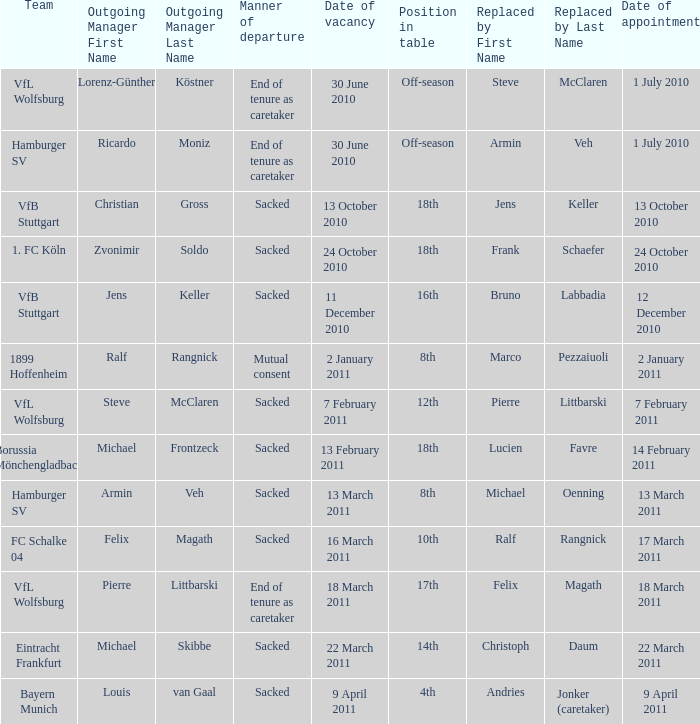When steve mcclaren is the replacer what is the manner of departure? End of tenure as caretaker. 